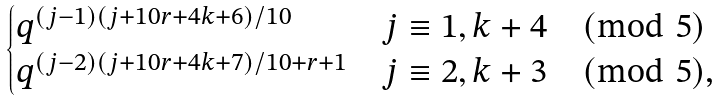Convert formula to latex. <formula><loc_0><loc_0><loc_500><loc_500>\begin{cases} q ^ { ( j - 1 ) ( j + 1 0 r + 4 k + 6 ) / 1 0 } & \text {$j\equiv 1,k+4 \pmod{5}$} \\ q ^ { ( j - 2 ) ( j + 1 0 r + 4 k + 7 ) / 1 0 + r + 1 } & \text {$j\equiv 2,k+3 \pmod{5}$,} \end{cases}</formula> 